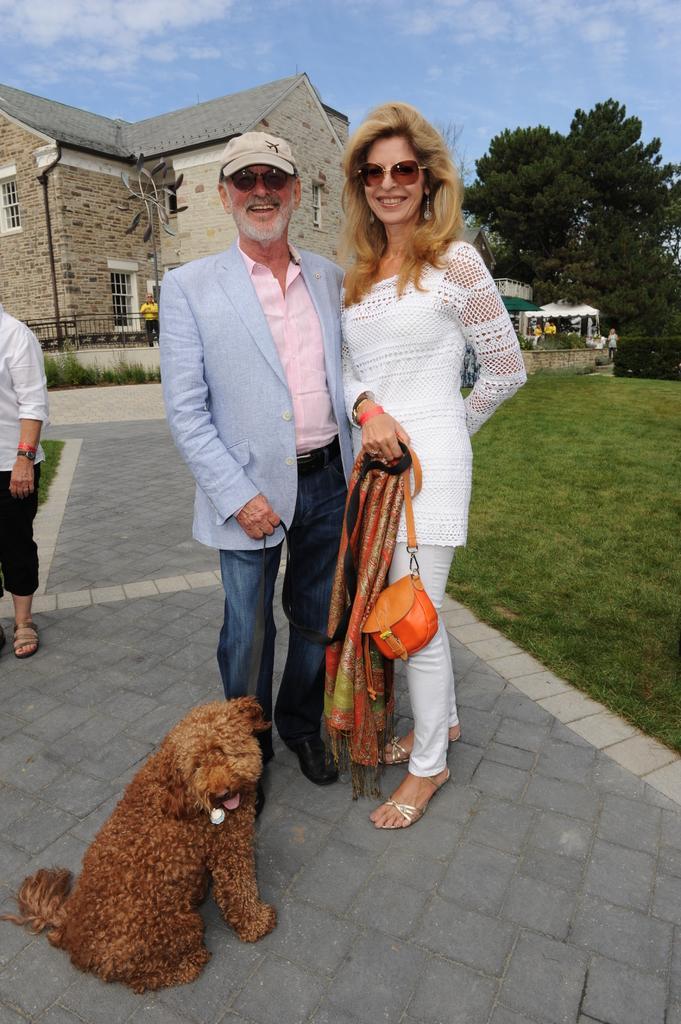How would you summarize this image in a sentence or two? In this image we can see two persons are standing on the ground and there is a dog in front of them. In the background we can see trees, building and sky. 